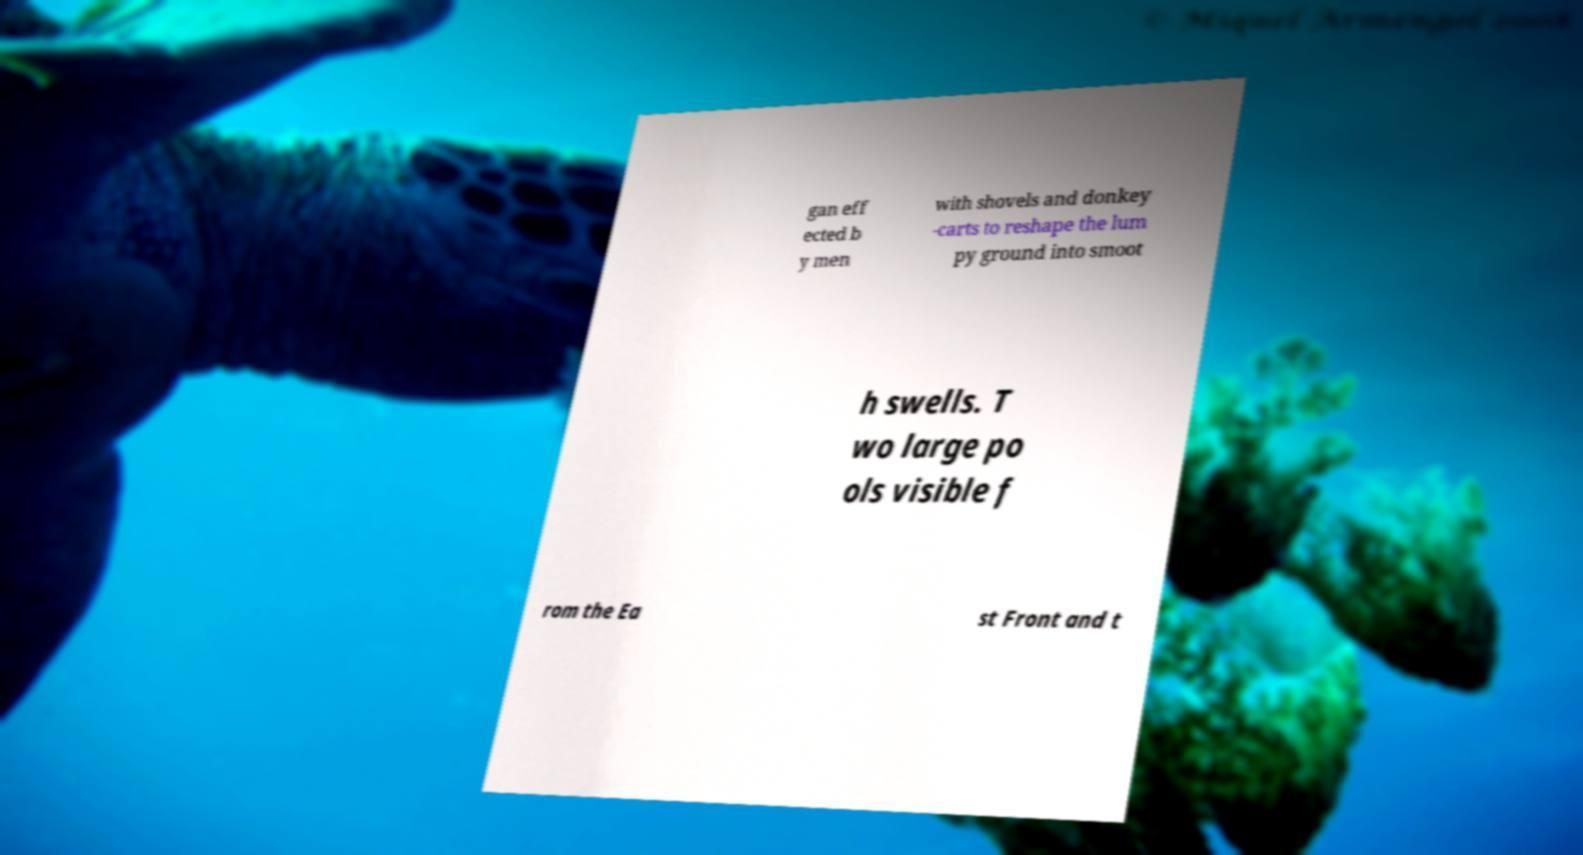Please read and relay the text visible in this image. What does it say? gan eff ected b y men with shovels and donkey -carts to reshape the lum py ground into smoot h swells. T wo large po ols visible f rom the Ea st Front and t 